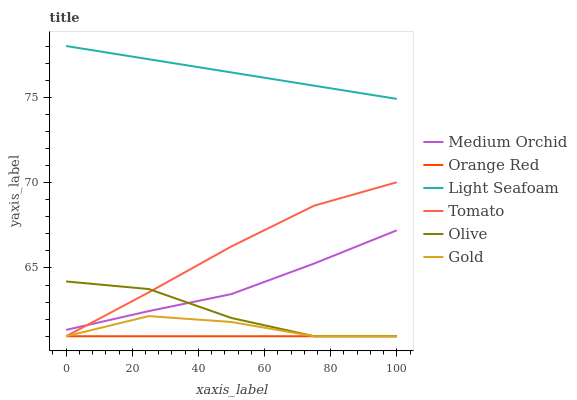Does Orange Red have the minimum area under the curve?
Answer yes or no. Yes. Does Light Seafoam have the maximum area under the curve?
Answer yes or no. Yes. Does Gold have the minimum area under the curve?
Answer yes or no. No. Does Gold have the maximum area under the curve?
Answer yes or no. No. Is Orange Red the smoothest?
Answer yes or no. Yes. Is Olive the roughest?
Answer yes or no. Yes. Is Gold the smoothest?
Answer yes or no. No. Is Gold the roughest?
Answer yes or no. No. Does Tomato have the lowest value?
Answer yes or no. Yes. Does Medium Orchid have the lowest value?
Answer yes or no. No. Does Light Seafoam have the highest value?
Answer yes or no. Yes. Does Gold have the highest value?
Answer yes or no. No. Is Orange Red less than Medium Orchid?
Answer yes or no. Yes. Is Medium Orchid greater than Orange Red?
Answer yes or no. Yes. Does Orange Red intersect Gold?
Answer yes or no. Yes. Is Orange Red less than Gold?
Answer yes or no. No. Is Orange Red greater than Gold?
Answer yes or no. No. Does Orange Red intersect Medium Orchid?
Answer yes or no. No. 